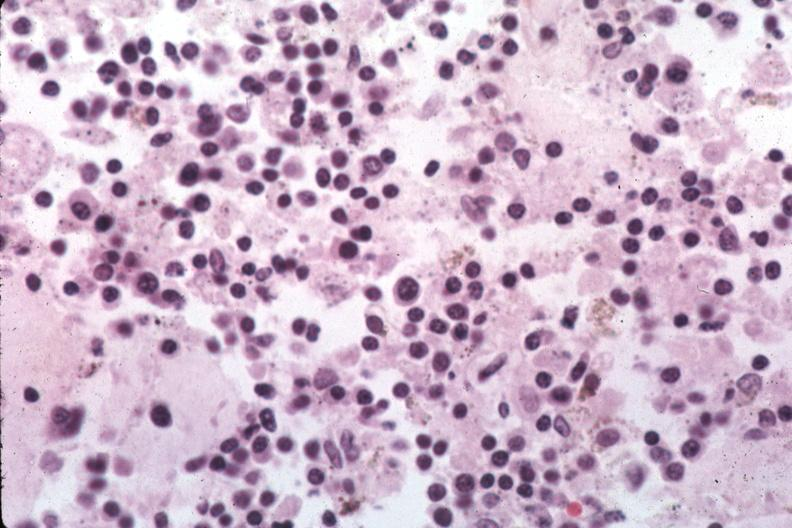s hematologic present?
Answer the question using a single word or phrase. Yes 